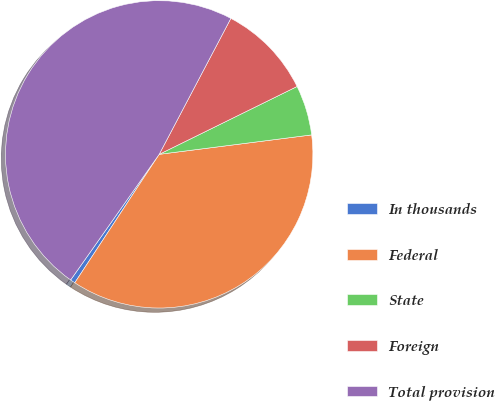<chart> <loc_0><loc_0><loc_500><loc_500><pie_chart><fcel>In thousands<fcel>Federal<fcel>State<fcel>Foreign<fcel>Total provision<nl><fcel>0.52%<fcel>36.27%<fcel>5.26%<fcel>10.0%<fcel>47.95%<nl></chart> 